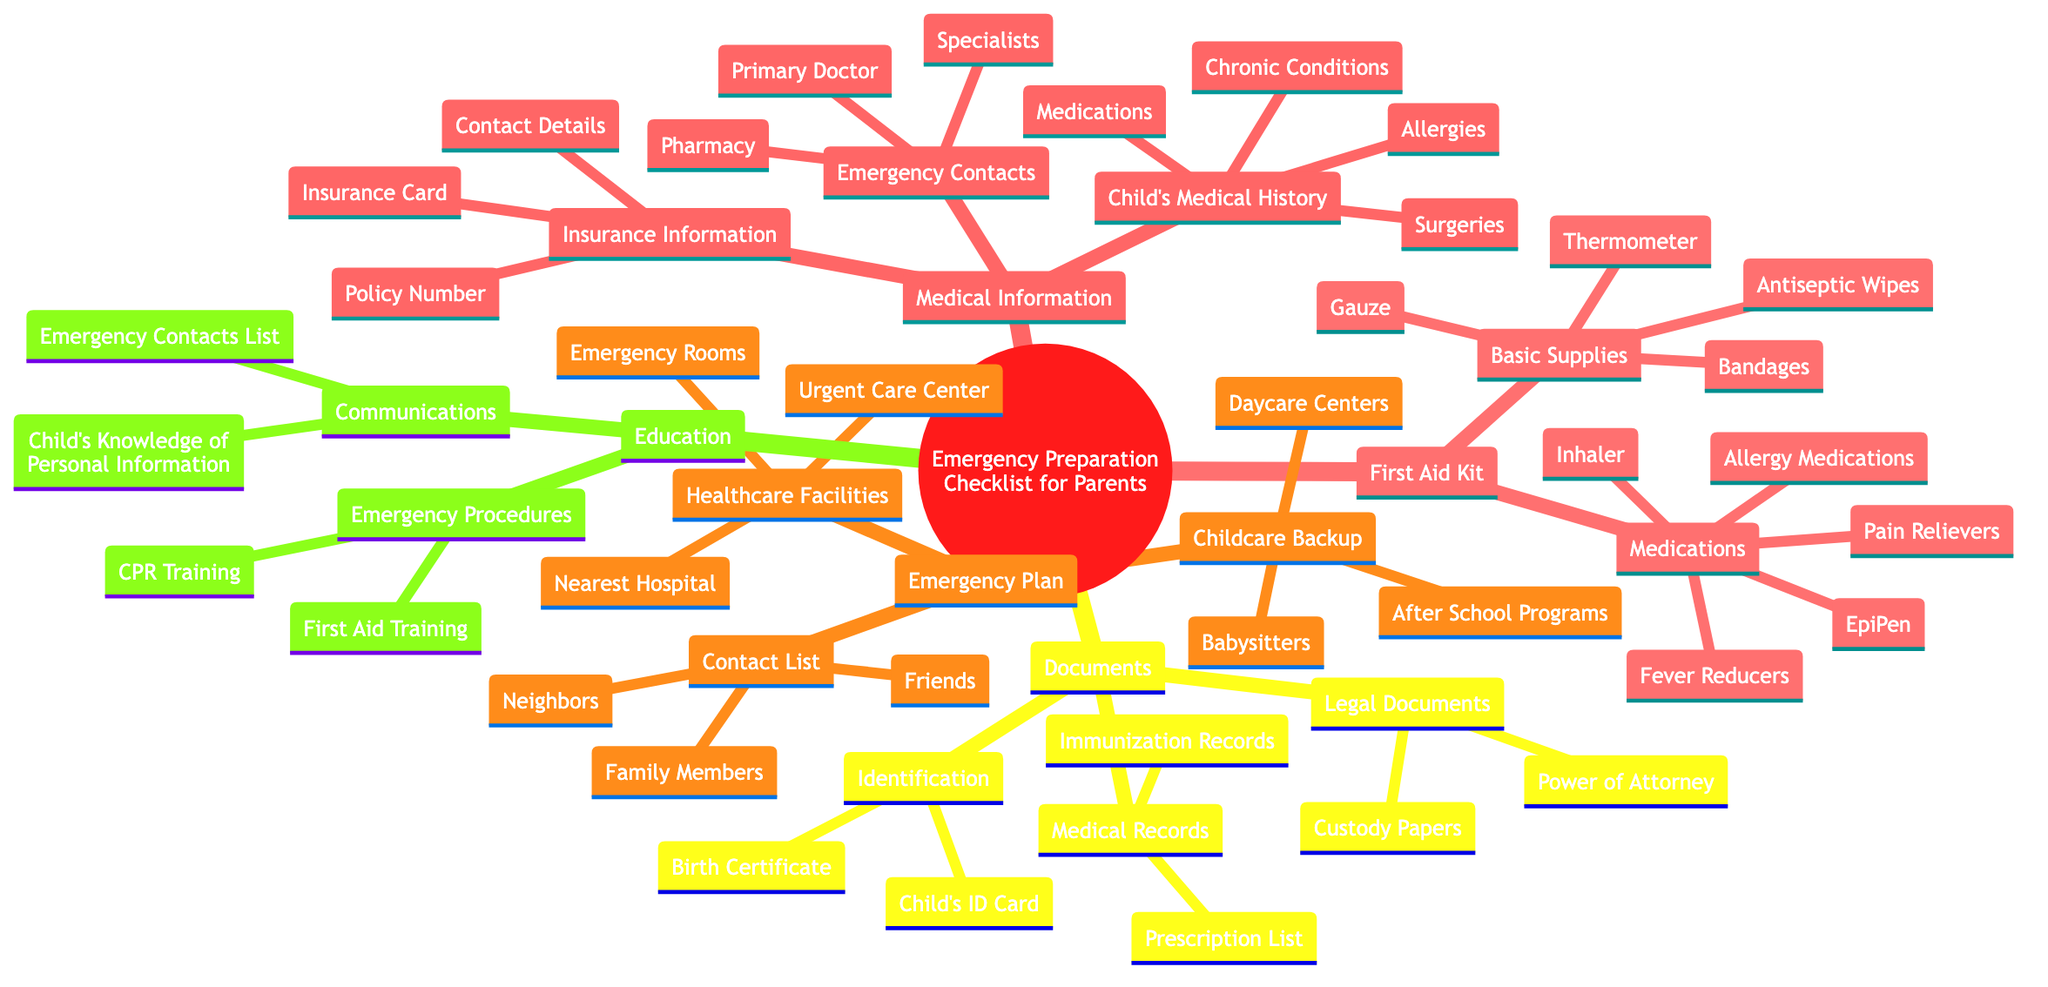What categories are included in the Emergency Preparation Checklist? The diagram presents five main categories under the Emergency Preparation Checklist: Medical Information, First Aid Kit, Emergency Plan, Documents, and Education.
Answer: Five How many items are listed under Medical Information? In the Medical Information category, there are three main items: Child's Medical History, Emergency Contacts, and Insurance Information, leading to a total of six sub-items.
Answer: Six What are the basic supplies in the First Aid Kit? The First Aid Kit contains four basic supplies: Bandages, Antiseptic Wipes, Gauze, and Thermometer, listed directly under the Basic Supplies node.
Answer: Bandages, Antiseptic Wipes, Gauze, Thermometer Which types of contact information are included in the Emergency Plan category? The Emergency Plan category includes a Contact List for Family Members, Friends, and Neighbors, along with Healthcare Facilities (Nearest Hospital, Urgent Care Center, Emergency Rooms) and Childcare Backup (Babysitters, Daycare Centers, After School Programs).
Answer: Family Members, Friends, Neighbors What legal documents are part of the Documents section? The Documents category lists two types of legal documents: Custody Papers and Power of Attorney, represented under the Legal Documents node.
Answer: Custody Papers, Power of Attorney What is the total number of medications specified in the First Aid Kit? Under the Medications section of the First Aid Kit, there are five listed items: Pain Relievers, Fever Reducers, Allergy Medications, Inhaler (if needed), and EpiPen (if needed). Summing these provides a total of five medications.
Answer: Five What educational procedures are included for emergency preparation? The Education category contains two educational procedures: CPR Training and First Aid Training, which are outlined under the Emergency Procedures.
Answer: CPR Training, First Aid Training How can a parent identify their child's allergies? Under the Medical Information section in Child's Medical History, allergies are specifically listed as a key piece of medical information that a parent can identify.
Answer: Allergies What is included in the child's identification within the Documents section? The Documents section lists identification specifically including Child's ID Card and Birth Certificate under the Identification node.
Answer: Child's ID Card, Birth Certificate 